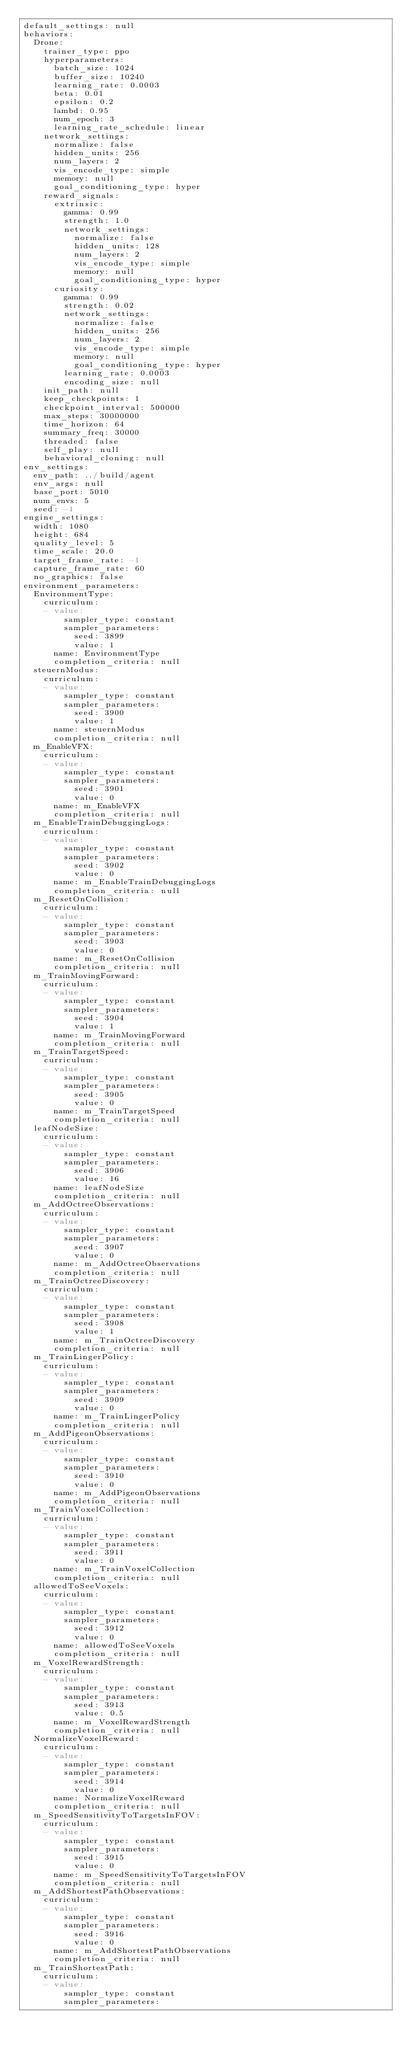<code> <loc_0><loc_0><loc_500><loc_500><_YAML_>default_settings: null
behaviors:
  Drone:
    trainer_type: ppo
    hyperparameters:
      batch_size: 1024
      buffer_size: 10240
      learning_rate: 0.0003
      beta: 0.01
      epsilon: 0.2
      lambd: 0.95
      num_epoch: 3
      learning_rate_schedule: linear
    network_settings:
      normalize: false
      hidden_units: 256
      num_layers: 2
      vis_encode_type: simple
      memory: null
      goal_conditioning_type: hyper
    reward_signals:
      extrinsic:
        gamma: 0.99
        strength: 1.0
        network_settings:
          normalize: false
          hidden_units: 128
          num_layers: 2
          vis_encode_type: simple
          memory: null
          goal_conditioning_type: hyper
      curiosity:
        gamma: 0.99
        strength: 0.02
        network_settings:
          normalize: false
          hidden_units: 256
          num_layers: 2
          vis_encode_type: simple
          memory: null
          goal_conditioning_type: hyper
        learning_rate: 0.0003
        encoding_size: null
    init_path: null
    keep_checkpoints: 1
    checkpoint_interval: 500000
    max_steps: 30000000
    time_horizon: 64
    summary_freq: 30000
    threaded: false
    self_play: null
    behavioral_cloning: null
env_settings:
  env_path: ../build/agent
  env_args: null
  base_port: 5010
  num_envs: 5
  seed: -1
engine_settings:
  width: 1080
  height: 684
  quality_level: 5
  time_scale: 20.0
  target_frame_rate: -1
  capture_frame_rate: 60
  no_graphics: false
environment_parameters:
  EnvironmentType:
    curriculum:
    - value:
        sampler_type: constant
        sampler_parameters:
          seed: 3899
          value: 1
      name: EnvironmentType
      completion_criteria: null
  steuernModus:
    curriculum:
    - value:
        sampler_type: constant
        sampler_parameters:
          seed: 3900
          value: 1
      name: steuernModus
      completion_criteria: null
  m_EnableVFX:
    curriculum:
    - value:
        sampler_type: constant
        sampler_parameters:
          seed: 3901
          value: 0
      name: m_EnableVFX
      completion_criteria: null
  m_EnableTrainDebuggingLogs:
    curriculum:
    - value:
        sampler_type: constant
        sampler_parameters:
          seed: 3902
          value: 0
      name: m_EnableTrainDebuggingLogs
      completion_criteria: null
  m_ResetOnCollision:
    curriculum:
    - value:
        sampler_type: constant
        sampler_parameters:
          seed: 3903
          value: 0
      name: m_ResetOnCollision
      completion_criteria: null
  m_TrainMovingForward:
    curriculum:
    - value:
        sampler_type: constant
        sampler_parameters:
          seed: 3904
          value: 1
      name: m_TrainMovingForward
      completion_criteria: null
  m_TrainTargetSpeed:
    curriculum:
    - value:
        sampler_type: constant
        sampler_parameters:
          seed: 3905
          value: 0
      name: m_TrainTargetSpeed
      completion_criteria: null
  leafNodeSize:
    curriculum:
    - value:
        sampler_type: constant
        sampler_parameters:
          seed: 3906
          value: 16
      name: leafNodeSize
      completion_criteria: null
  m_AddOctreeObservations:
    curriculum:
    - value:
        sampler_type: constant
        sampler_parameters:
          seed: 3907
          value: 0
      name: m_AddOctreeObservations
      completion_criteria: null
  m_TrainOctreeDiscovery:
    curriculum:
    - value:
        sampler_type: constant
        sampler_parameters:
          seed: 3908
          value: 1
      name: m_TrainOctreeDiscovery
      completion_criteria: null
  m_TrainLingerPolicy:
    curriculum:
    - value:
        sampler_type: constant
        sampler_parameters:
          seed: 3909
          value: 0
      name: m_TrainLingerPolicy
      completion_criteria: null
  m_AddPigeonObservations:
    curriculum:
    - value:
        sampler_type: constant
        sampler_parameters:
          seed: 3910
          value: 0
      name: m_AddPigeonObservations
      completion_criteria: null
  m_TrainVoxelCollection:
    curriculum:
    - value:
        sampler_type: constant
        sampler_parameters:
          seed: 3911
          value: 0
      name: m_TrainVoxelCollection
      completion_criteria: null
  allowedToSeeVoxels:
    curriculum:
    - value:
        sampler_type: constant
        sampler_parameters:
          seed: 3912
          value: 0
      name: allowedToSeeVoxels
      completion_criteria: null
  m_VoxelRewardStrength:
    curriculum:
    - value:
        sampler_type: constant
        sampler_parameters:
          seed: 3913
          value: 0.5
      name: m_VoxelRewardStrength
      completion_criteria: null
  NormalizeVoxelReward:
    curriculum:
    - value:
        sampler_type: constant
        sampler_parameters:
          seed: 3914
          value: 0
      name: NormalizeVoxelReward
      completion_criteria: null
  m_SpeedSensitivityToTargetsInFOV:
    curriculum:
    - value:
        sampler_type: constant
        sampler_parameters:
          seed: 3915
          value: 0
      name: m_SpeedSensitivityToTargetsInFOV
      completion_criteria: null
  m_AddShortestPathObservations:
    curriculum:
    - value:
        sampler_type: constant
        sampler_parameters:
          seed: 3916
          value: 0
      name: m_AddShortestPathObservations
      completion_criteria: null
  m_TrainShortestPath:
    curriculum:
    - value:
        sampler_type: constant
        sampler_parameters:</code> 